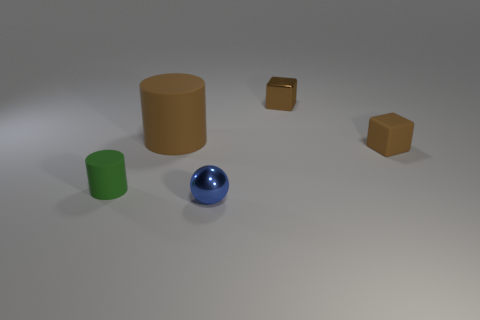What number of things are either blue balls or objects that are behind the small ball?
Give a very brief answer. 5. Do the small green cylinder in front of the brown rubber cube and the small blue object have the same material?
Your response must be concise. No. Is there anything else that is the same size as the brown matte cylinder?
Keep it short and to the point. No. What is the thing that is to the right of the metal thing that is behind the sphere made of?
Your answer should be very brief. Rubber. Are there more tiny brown cubes in front of the shiny block than small spheres behind the brown rubber block?
Offer a terse response. Yes. The brown rubber cylinder has what size?
Make the answer very short. Large. There is a thing that is on the right side of the brown metal block; does it have the same color as the big matte object?
Provide a short and direct response. Yes. Are there any other things that have the same shape as the blue thing?
Your answer should be very brief. No. There is a tiny rubber object that is behind the green matte cylinder; are there any cylinders that are behind it?
Make the answer very short. Yes. Is the number of tiny metallic things behind the tiny matte cylinder less than the number of small objects that are behind the small metal ball?
Ensure brevity in your answer.  Yes. 